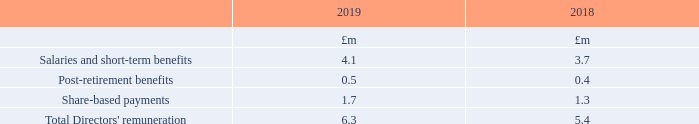8 Directors’ emoluments
Directors represent the key management personnel of the Group under the terms of IAS 24 (Related Party Disclosures). Total remuneration is shown below.
Further details of salaries and short-term benefits, post-retirement benefits, share plans and long-term share incentive plans are shown in the Annual Report on Remuneration 2019 on pages 102 to 132. The share-based payments charge comprises a charge in relation to the Performance Share Plan and the Employee Share Ownership Plan (as described in Note 23).
What details are shown in the Annual Report on Remuneration 2019? Further details of salaries and short-term benefits, post-retirement benefits, share plans and long-term share incentive plans. What do the share-based payments charge comprise? A charge in relation to the performance share plan and the employee share ownership plan (as described in note 23). What are the components considered in the calculation of the Total Directors' remuneration? Salaries and short-term benefits, post-retirement benefits, share-based payments. In which year was the share-based payments larger? 1.7>1.3
Answer: 2019. What was the change in the total directors' remuneration in 2019 from 2018?
Answer scale should be: million. 6.3-5.4
Answer: 0.9. What was the percentage change in the total directors' remuneration in 2019 from 2018?
Answer scale should be: percent. (6.3-5.4)/5.4
Answer: 16.67. 